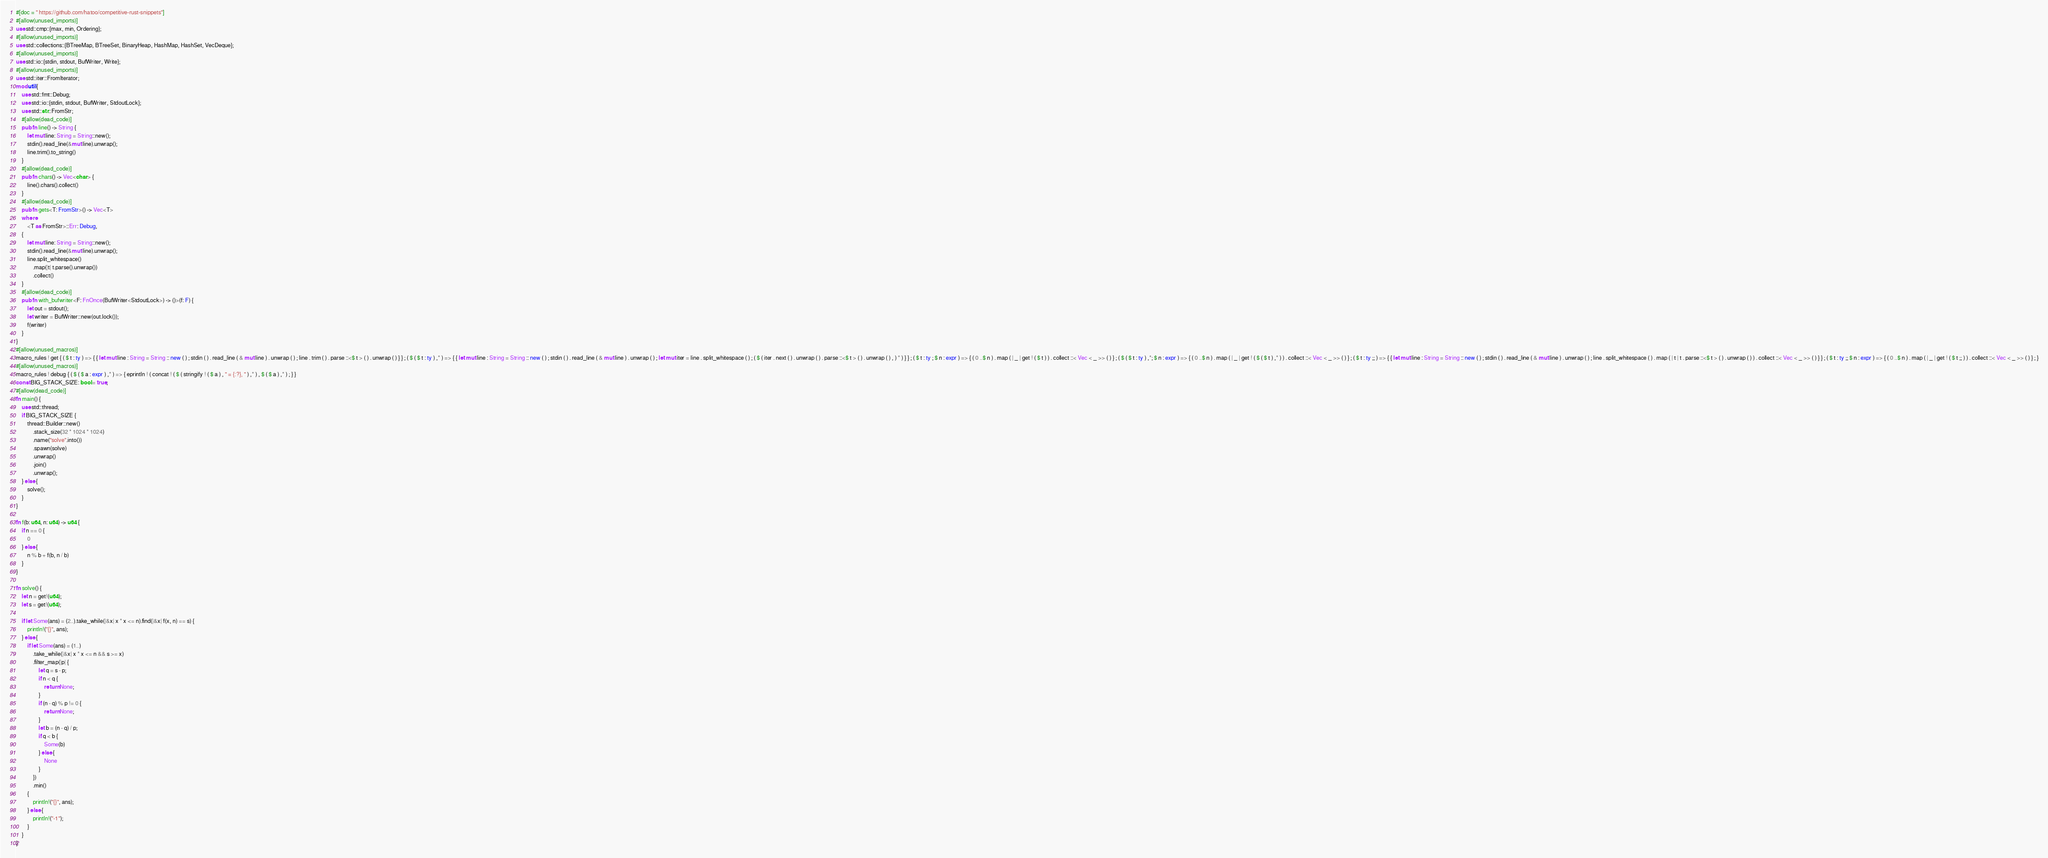Convert code to text. <code><loc_0><loc_0><loc_500><loc_500><_Rust_>#[doc = " https://github.com/hatoo/competitive-rust-snippets"]
#[allow(unused_imports)]
use std::cmp::{max, min, Ordering};
#[allow(unused_imports)]
use std::collections::{BTreeMap, BTreeSet, BinaryHeap, HashMap, HashSet, VecDeque};
#[allow(unused_imports)]
use std::io::{stdin, stdout, BufWriter, Write};
#[allow(unused_imports)]
use std::iter::FromIterator;
mod util {
    use std::fmt::Debug;
    use std::io::{stdin, stdout, BufWriter, StdoutLock};
    use std::str::FromStr;
    #[allow(dead_code)]
    pub fn line() -> String {
        let mut line: String = String::new();
        stdin().read_line(&mut line).unwrap();
        line.trim().to_string()
    }
    #[allow(dead_code)]
    pub fn chars() -> Vec<char> {
        line().chars().collect()
    }
    #[allow(dead_code)]
    pub fn gets<T: FromStr>() -> Vec<T>
    where
        <T as FromStr>::Err: Debug,
    {
        let mut line: String = String::new();
        stdin().read_line(&mut line).unwrap();
        line.split_whitespace()
            .map(|t| t.parse().unwrap())
            .collect()
    }
    #[allow(dead_code)]
    pub fn with_bufwriter<F: FnOnce(BufWriter<StdoutLock>) -> ()>(f: F) {
        let out = stdout();
        let writer = BufWriter::new(out.lock());
        f(writer)
    }
}
#[allow(unused_macros)]
macro_rules ! get { ( $ t : ty ) => { { let mut line : String = String :: new ( ) ; stdin ( ) . read_line ( & mut line ) . unwrap ( ) ; line . trim ( ) . parse ::<$ t > ( ) . unwrap ( ) } } ; ( $ ( $ t : ty ) ,* ) => { { let mut line : String = String :: new ( ) ; stdin ( ) . read_line ( & mut line ) . unwrap ( ) ; let mut iter = line . split_whitespace ( ) ; ( $ ( iter . next ( ) . unwrap ( ) . parse ::<$ t > ( ) . unwrap ( ) , ) * ) } } ; ( $ t : ty ; $ n : expr ) => { ( 0 ..$ n ) . map ( | _ | get ! ( $ t ) ) . collect ::< Vec < _ >> ( ) } ; ( $ ( $ t : ty ) ,*; $ n : expr ) => { ( 0 ..$ n ) . map ( | _ | get ! ( $ ( $ t ) ,* ) ) . collect ::< Vec < _ >> ( ) } ; ( $ t : ty ;; ) => { { let mut line : String = String :: new ( ) ; stdin ( ) . read_line ( & mut line ) . unwrap ( ) ; line . split_whitespace ( ) . map ( | t | t . parse ::<$ t > ( ) . unwrap ( ) ) . collect ::< Vec < _ >> ( ) } } ; ( $ t : ty ;; $ n : expr ) => { ( 0 ..$ n ) . map ( | _ | get ! ( $ t ;; ) ) . collect ::< Vec < _ >> ( ) } ; }
#[allow(unused_macros)]
macro_rules ! debug { ( $ ( $ a : expr ) ,* ) => { eprintln ! ( concat ! ( $ ( stringify ! ( $ a ) , " = {:?}, " ) ,* ) , $ ( $ a ) ,* ) ; } }
const BIG_STACK_SIZE: bool = true;
#[allow(dead_code)]
fn main() {
    use std::thread;
    if BIG_STACK_SIZE {
        thread::Builder::new()
            .stack_size(32 * 1024 * 1024)
            .name("solve".into())
            .spawn(solve)
            .unwrap()
            .join()
            .unwrap();
    } else {
        solve();
    }
}

fn f(b: u64, n: u64) -> u64 {
    if n == 0 {
        0
    } else {
        n % b + f(b, n / b)
    }
}

fn solve() {
    let n = get!(u64);
    let s = get!(u64);

    if let Some(ans) = (2..).take_while(|&x| x * x <= n).find(|&x| f(x, n) == s) {
        println!("{}", ans);
    } else {
        if let Some(ans) = (1..)
            .take_while(|&x| x * x <= n && s >= x)
            .filter_map(|p| {
                let q = s - p;
                if n < q {
                    return None;
                }
                if (n - q) % p != 0 {
                    return None;
                }
                let b = (n - q) / p;
                if q < b {
                    Some(b)
                } else {
                    None
                }
            })
            .min()
        {
            println!("{}", ans);
        } else {
            println!("-1");
        }
    }
}
</code> 